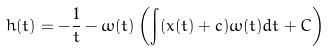Convert formula to latex. <formula><loc_0><loc_0><loc_500><loc_500>h ( t ) = - \frac { 1 } { t } - \omega ( t ) \left ( \int ( x ( t ) + c ) \omega ( t ) d t + C \right )</formula> 